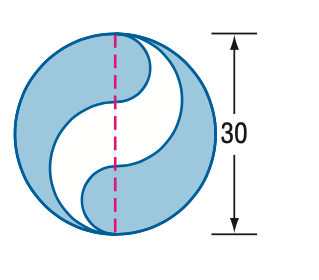Question: Find the area of the shaded region. Round to the nearest tenth.
Choices:
A. 392.7
B. 471.2
C. 589.0
D. 785.4
Answer with the letter. Answer: B 